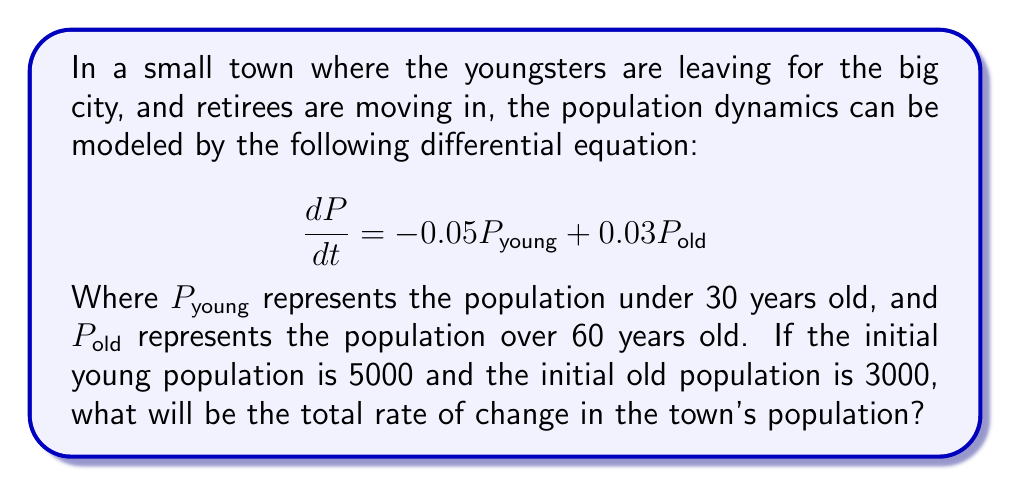What is the answer to this math problem? Let's approach this step-by-step:

1) We are given the differential equation:
   $$\frac{dP}{dt} = -0.05P_{young} + 0.03P_{old}$$

2) We know the initial populations:
   $P_{young} = 5000$
   $P_{old} = 3000$

3) To find the total rate of change, we need to substitute these values into our equation:

   $$\frac{dP}{dt} = -0.05(5000) + 0.03(3000)$$

4) Let's calculate each term:
   $-0.05(5000) = -250$
   $0.03(3000) = 90$

5) Now, we can add these terms:

   $$\frac{dP}{dt} = -250 + 90 = -160$$

6) The negative sign indicates that the population is decreasing overall.
Answer: The total rate of change in the town's population is $-160$ people per time unit (likely per year). 